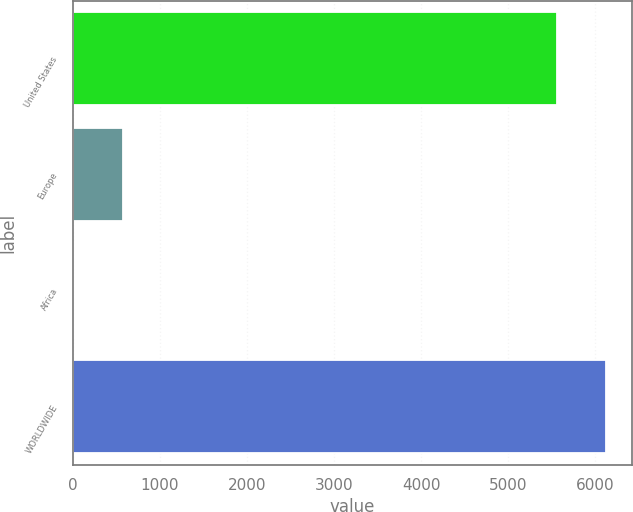Convert chart to OTSL. <chart><loc_0><loc_0><loc_500><loc_500><bar_chart><fcel>United States<fcel>Europe<fcel>Africa<fcel>WORLDWIDE<nl><fcel>5554<fcel>575.9<fcel>13<fcel>6116.9<nl></chart> 